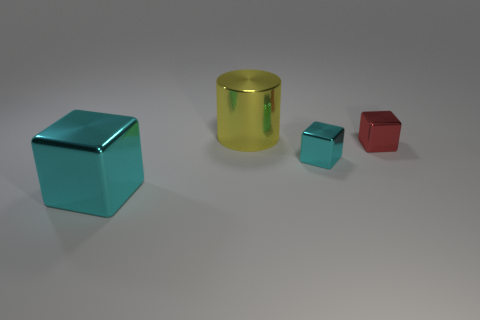Subtract all cyan blocks. How many blocks are left? 1 Add 2 yellow shiny cylinders. How many objects exist? 6 Subtract all gray balls. How many cyan cubes are left? 2 Subtract all cyan blocks. How many blocks are left? 1 Subtract all cylinders. How many objects are left? 3 Add 2 red metallic blocks. How many red metallic blocks are left? 3 Add 4 red shiny things. How many red shiny things exist? 5 Subtract 0 blue cylinders. How many objects are left? 4 Subtract 1 blocks. How many blocks are left? 2 Subtract all brown cubes. Subtract all cyan cylinders. How many cubes are left? 3 